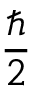<formula> <loc_0><loc_0><loc_500><loc_500>\frac { } { 2 }</formula> 